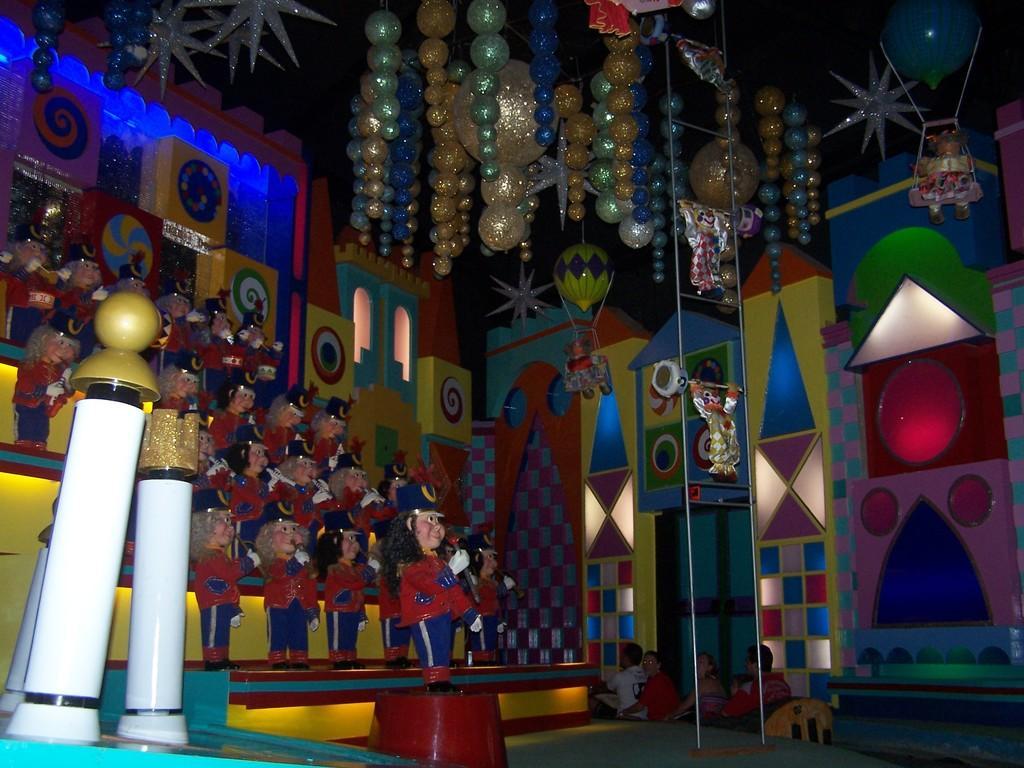How would you summarize this image in a sentence or two? In this image I see number of toys over here and I see the decoration on the top and I see few people over here and I see the colorful things over here and it is dark in the background. 